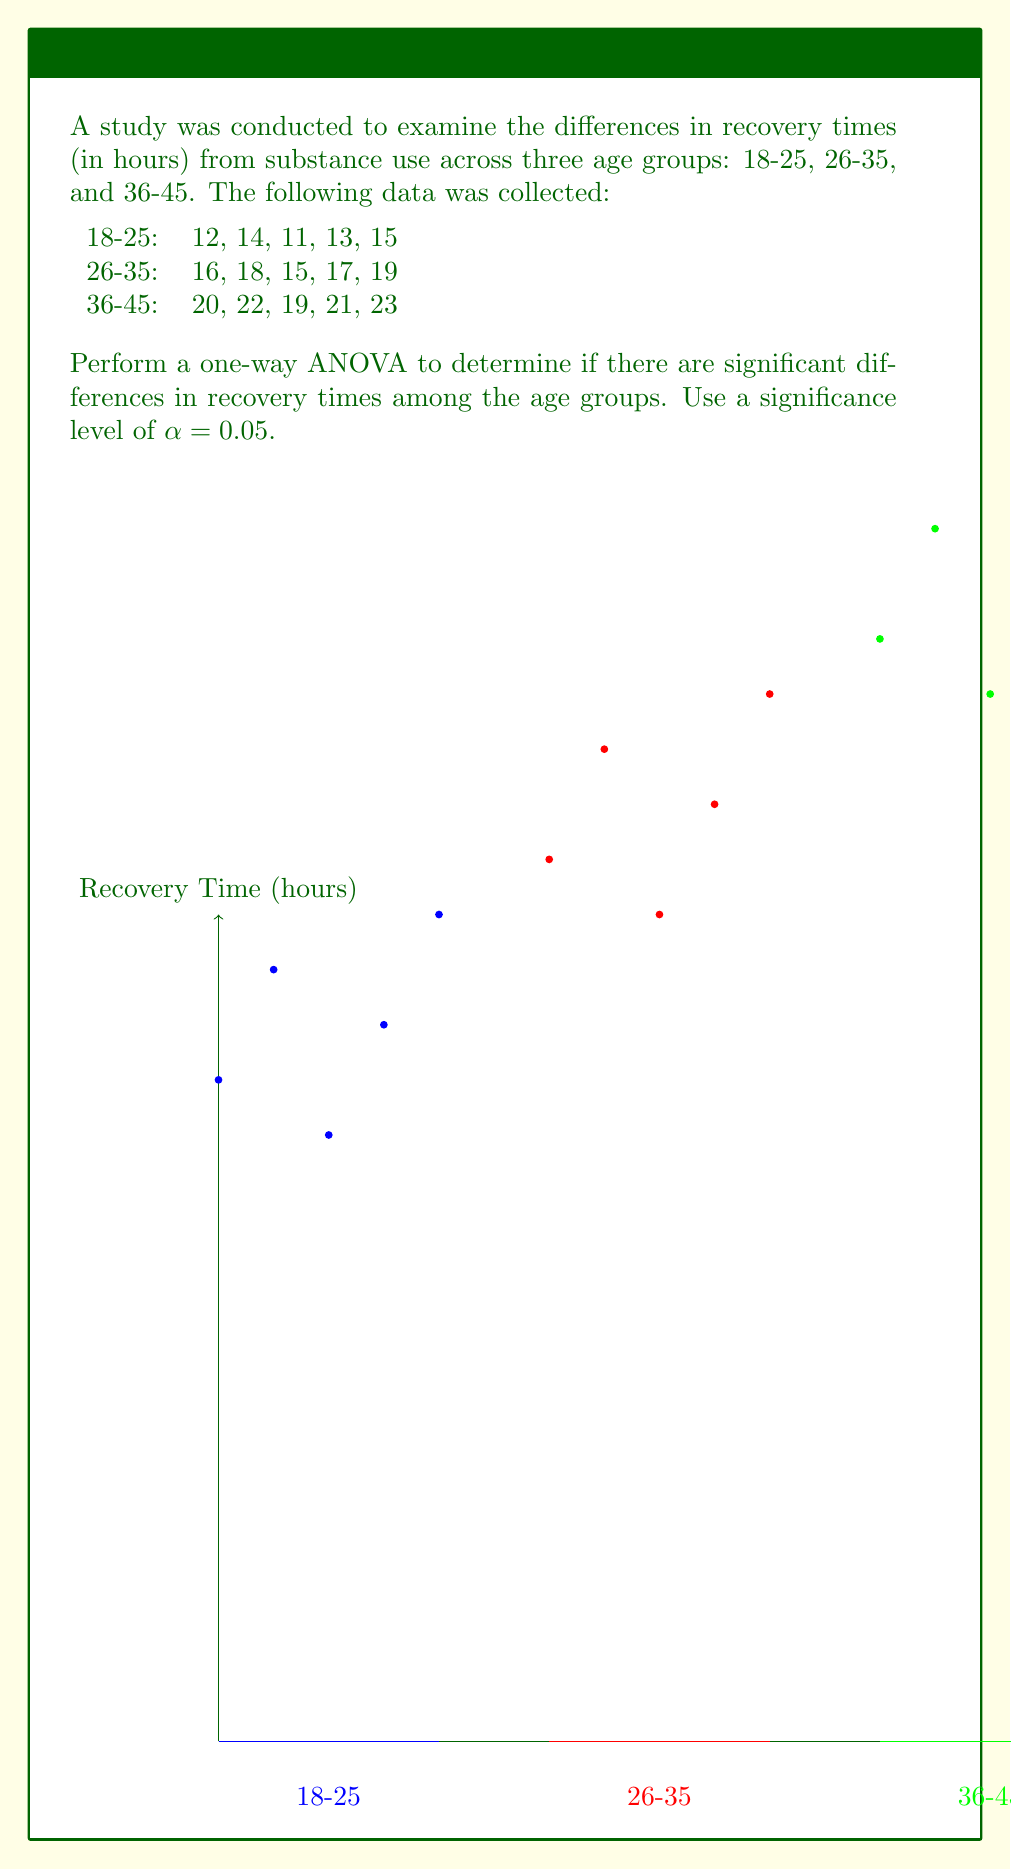Can you answer this question? Let's perform the one-way ANOVA step by step:

1. Calculate the sum of squares:

   a. Total sum of squares (SST):
      $$SST = \sum_{i=1}^{n} (x_i - \bar{x})^2$$
      where $\bar{x}$ is the grand mean.
      
   b. Between-group sum of squares (SSB):
      $$SSB = \sum_{i=1}^{k} n_i(\bar{x}_i - \bar{x})^2$$
      where $k$ is the number of groups, $n_i$ is the size of each group, and $\bar{x}_i$ is the mean of each group.
      
   c. Within-group sum of squares (SSW):
      $$SSW = SST - SSB$$

2. Calculate degrees of freedom:
   - Total df: $n - 1 = 15 - 1 = 14$
   - Between-group df: $k - 1 = 3 - 1 = 2$
   - Within-group df: $n - k = 15 - 3 = 12$

3. Calculate mean squares:
   $$MSB = \frac{SSB}{df_B}$$
   $$MSW = \frac{SSW}{df_W}$$

4. Calculate F-statistic:
   $$F = \frac{MSB}{MSW}$$

5. Compare F-statistic with critical F-value:
   $F_{critical} = F_{0.05, 2, 12}$ (from F-distribution table)

Calculations:
- Grand mean: $\bar{x} = 17$
- Group means: $\bar{x}_1 = 13$, $\bar{x}_2 = 17$, $\bar{x}_3 = 21$
- SST = 270
- SSB = 260
- SSW = 10
- MSB = 130
- MSW = 0.833
- F = 156

The critical F-value at α = 0.05 with df(2, 12) is approximately 3.89.

Since $F = 156 > F_{critical} = 3.89$, we reject the null hypothesis.
Answer: F(2,12) = 156, p < 0.05. Significant differences exist among age groups. 